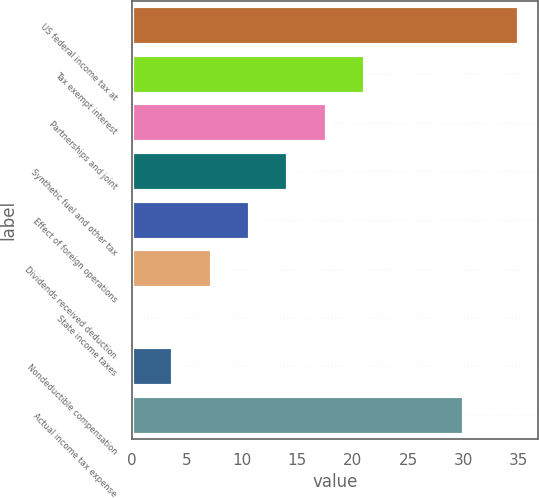Convert chart to OTSL. <chart><loc_0><loc_0><loc_500><loc_500><bar_chart><fcel>US federal income tax at<fcel>Tax exempt interest<fcel>Partnerships and joint<fcel>Synthetic fuel and other tax<fcel>Effect of foreign operations<fcel>Dividends received deduction<fcel>State income taxes<fcel>Nondeductible compensation<fcel>Actual income tax expense<nl><fcel>35<fcel>21.12<fcel>17.65<fcel>14.18<fcel>10.71<fcel>7.24<fcel>0.3<fcel>3.77<fcel>30.1<nl></chart> 